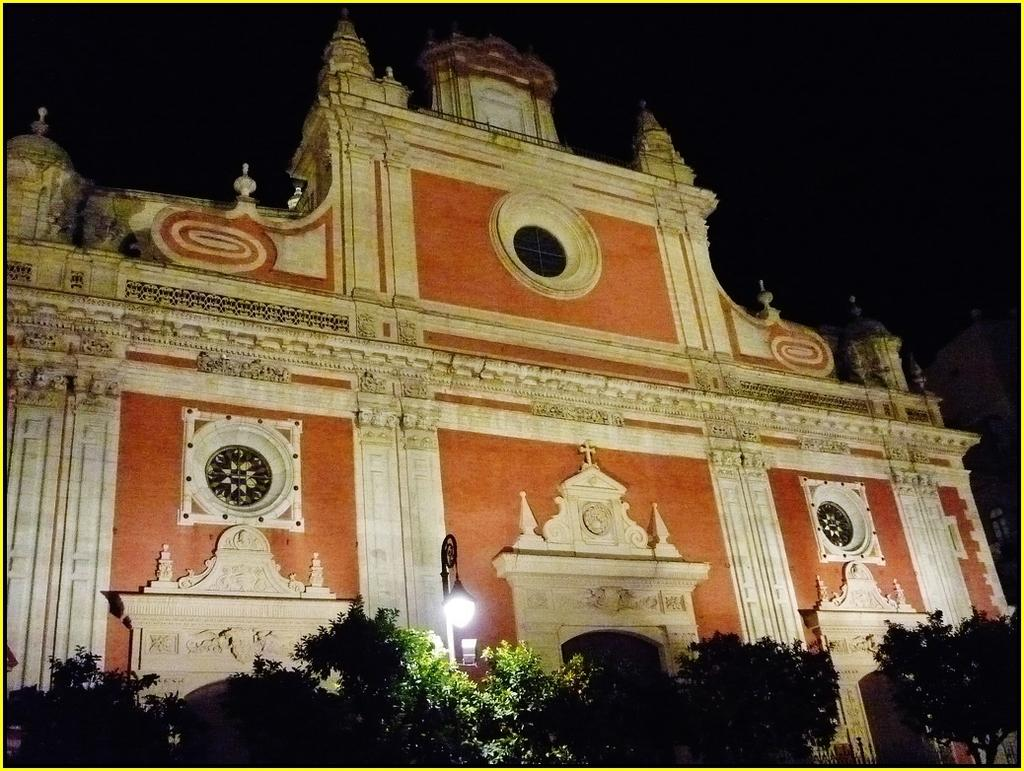What type of structure is visible in the image? There is a building in the image. What can be seen at the bottom of the image? There are many trees at the bottom of the image. What type of lighting is present near the building? There is a street light near the building. How would you describe the lighting at the top of the image? The top of the image appears to be dark. How many boats are docked near the building in the image? There are no boats visible in the image; it only features a building, trees, a street light, and a dark top portion. What type of grape is growing on the trees at the bottom of the image? There are no grapes present in the image; the trees are not specified as fruit-bearing trees. 